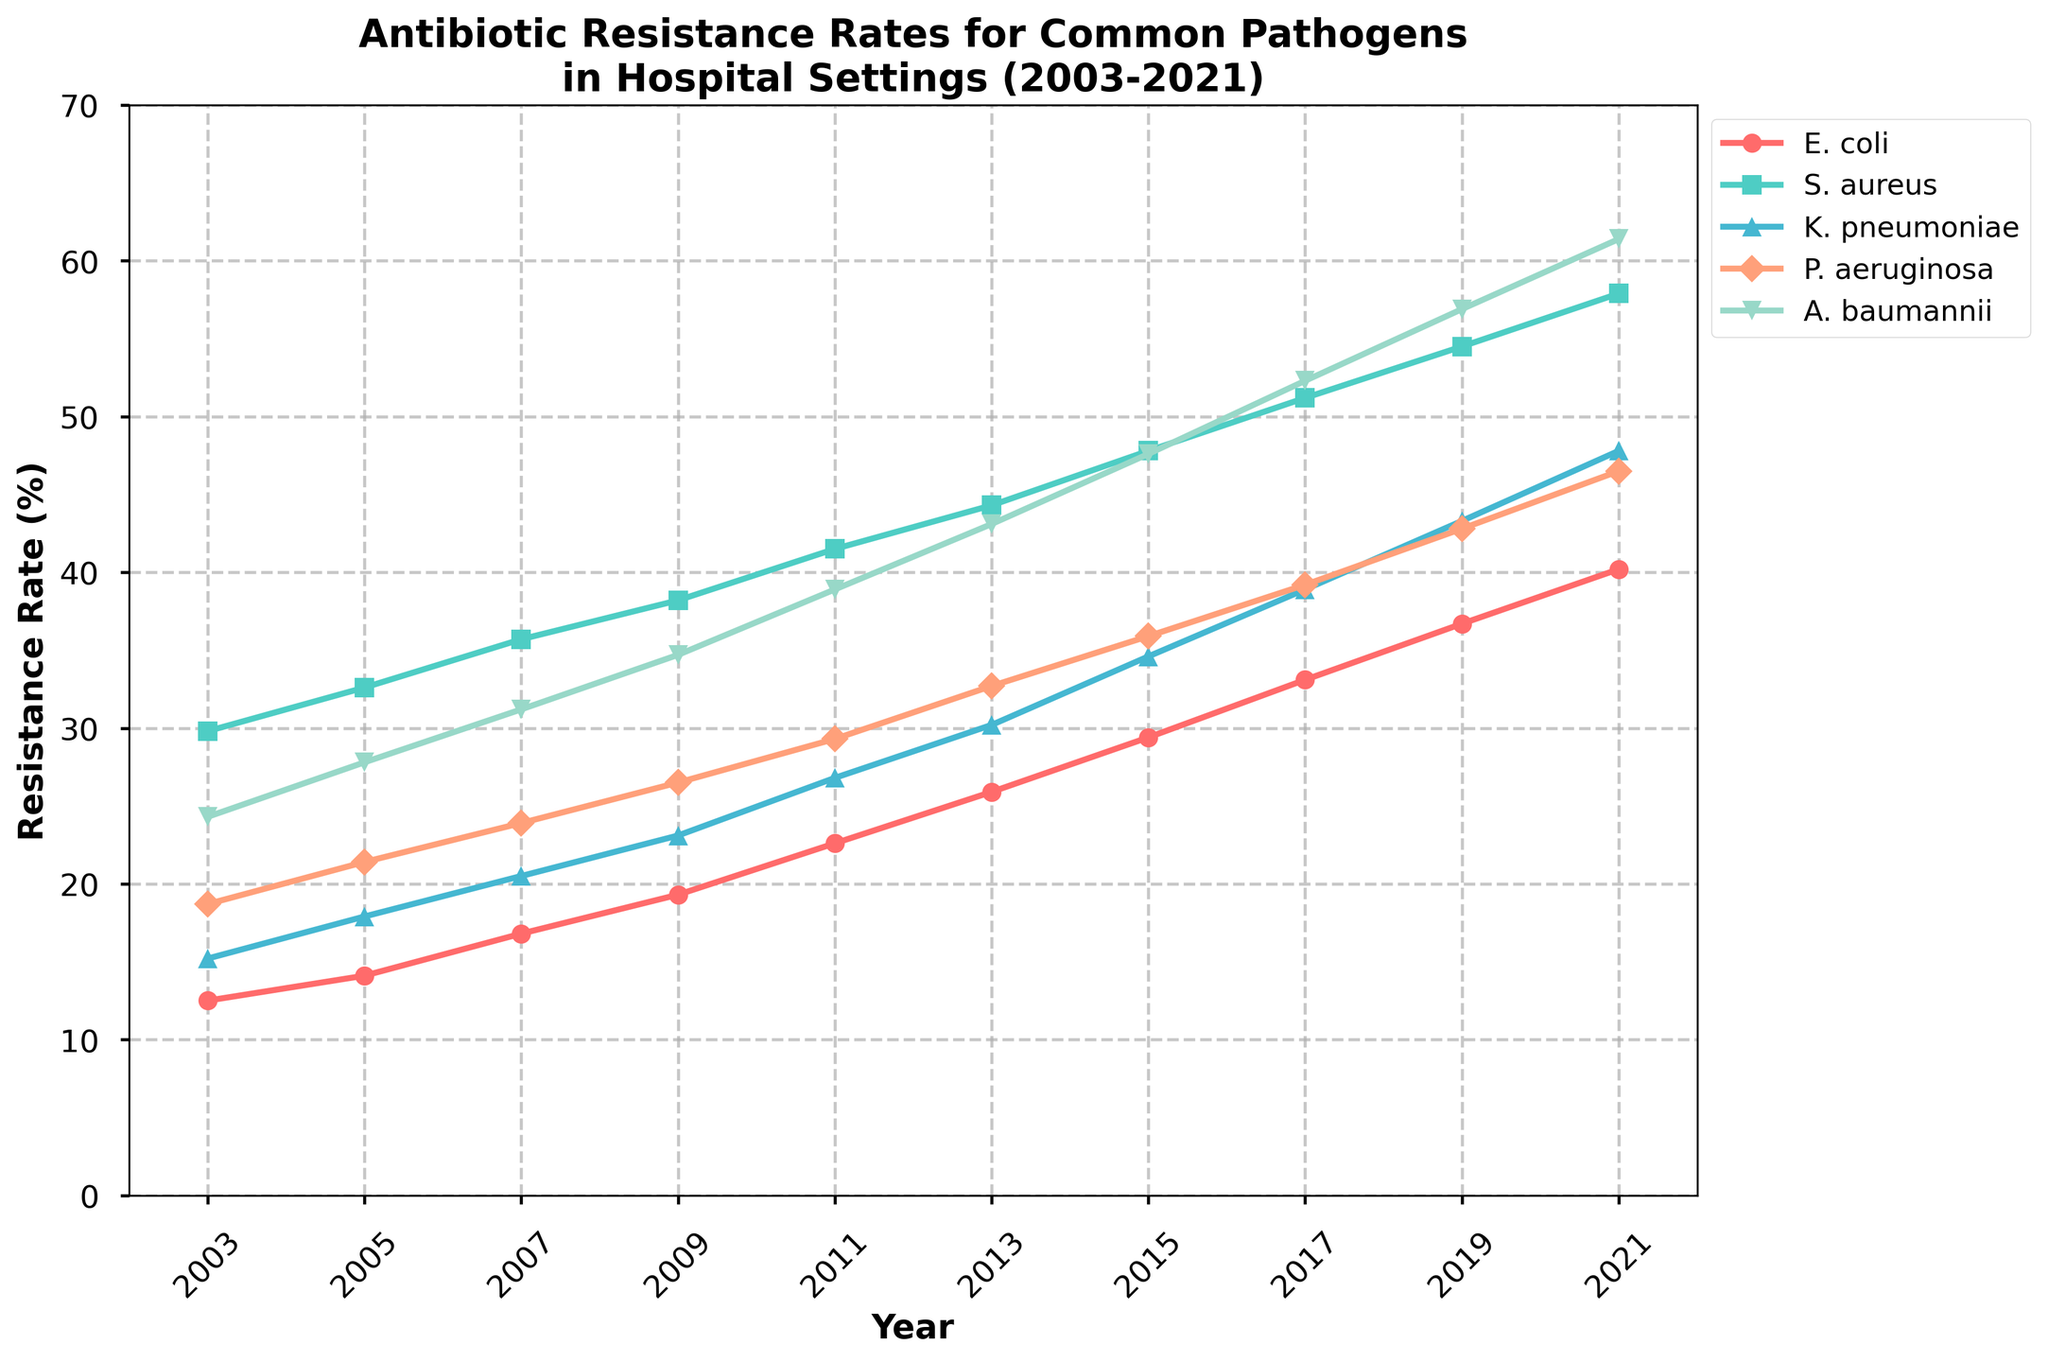Which pathogen has the highest resistance rate in 2021? To determine which pathogen has the highest resistance rate in 2021, look at the data points for each pathogen in that year. The highest value here is for A. baumannii.
Answer: A. baumannii What is the difference in resistance rates of K. pneumoniae between 2011 and 2021? Subtract the resistance rate of K. pneumoniae in 2011 (26.8%) from the rate in 2021 (47.8%). The calculation is 47.8% - 26.8% = 21%.
Answer: 21% How has the resistance rate of E. coli changed from 2003 to 2021? Calculate the change by subtracting the resistance rate of E. coli in 2003 (12.5%) from 2021 (40.2%). The calculation is 40.2% - 12.5% = 27.7%.
Answer: 27.7% Which pathogen shows the steepest increase in resistance rate between 2003 and 2021? Observe the line trends for all pathogens. A. baumannii starts at 24.3% in 2003 and goes to 61.4% in 2021, which seems steeper compared to the others.
Answer: A. baumannii What is the average resistance rate of S. aureus over the years shown? Sum the resistance rates of S. aureus for each year and divide by the number of years. (29.8 + 32.6 + 35.7 + 38.2 + 41.5 + 44.3 + 47.8 + 51.2 + 54.5 + 57.9) / 10 = 433.5 / 10 = 43.35%.
Answer: 43.35% In which year does P. aeruginosa first reach a resistance rate above 30%? Check the plot for increasing values of P. aeruginosa and identify the first year where the resistance rate exceeds 30%, which is 2013.
Answer: 2013 What is the overall trend of resistance rates for all pathogens from 2003 to 2021? All pathogen lines show an increasing trend over the years from 2003 to 2021, indicating a rise in resistance rates.
Answer: Increasing How much did A. baumannii's resistance rate grow between 2007 and 2015? Subtract the 2007 rate of A. baumannii (31.2%) from the 2015 rate (47.6%). The calculation is 47.6% - 31.2% = 16.4%.
Answer: 16.4% Which two pathogens have the closest resistance rates in 2019? Compare the 2019 data points for all pathogens. E. coli (36.7%) and P. aeruginosa (42.8%) are relatively closest, with the smallest difference.
Answer: E. coli and P. aeruginosa 